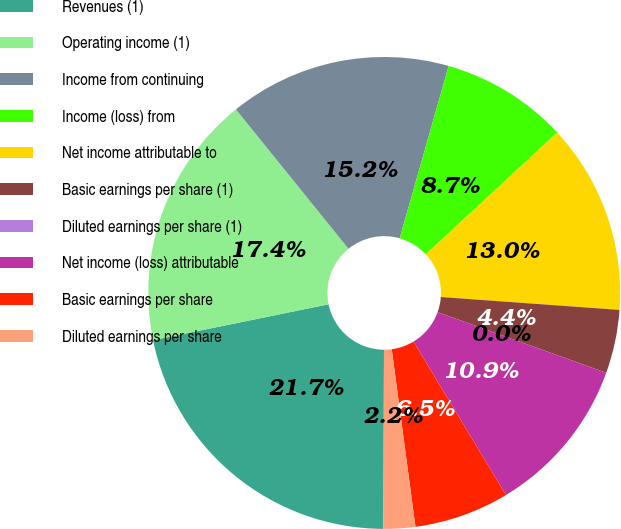Convert chart to OTSL. <chart><loc_0><loc_0><loc_500><loc_500><pie_chart><fcel>Revenues (1)<fcel>Operating income (1)<fcel>Income from continuing<fcel>Income (loss) from<fcel>Net income attributable to<fcel>Basic earnings per share (1)<fcel>Diluted earnings per share (1)<fcel>Net income (loss) attributable<fcel>Basic earnings per share<fcel>Diluted earnings per share<nl><fcel>21.74%<fcel>17.39%<fcel>15.22%<fcel>8.7%<fcel>13.04%<fcel>4.35%<fcel>0.0%<fcel>10.87%<fcel>6.52%<fcel>2.17%<nl></chart> 